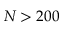<formula> <loc_0><loc_0><loc_500><loc_500>N > 2 0 0</formula> 